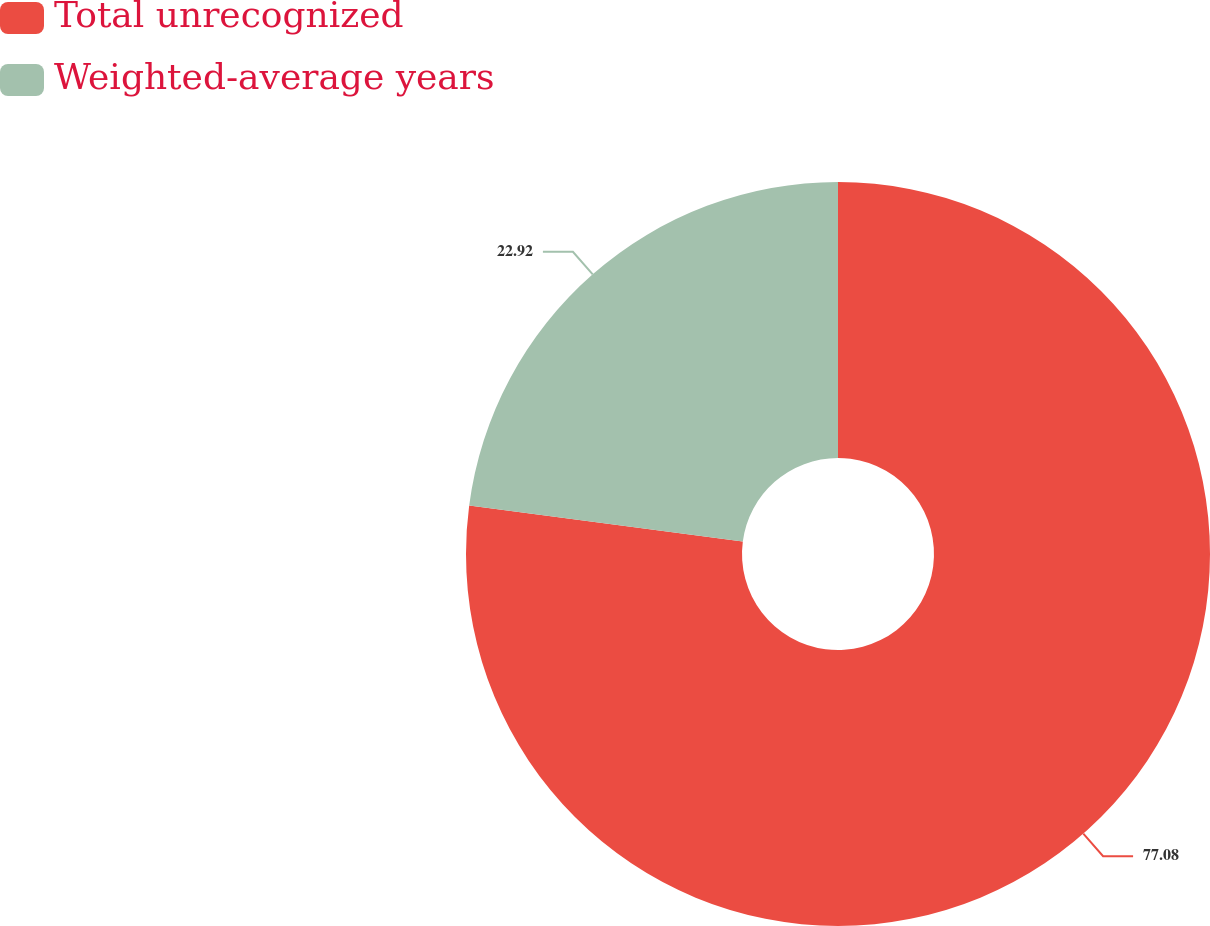Convert chart. <chart><loc_0><loc_0><loc_500><loc_500><pie_chart><fcel>Total unrecognized<fcel>Weighted-average years<nl><fcel>77.08%<fcel>22.92%<nl></chart> 